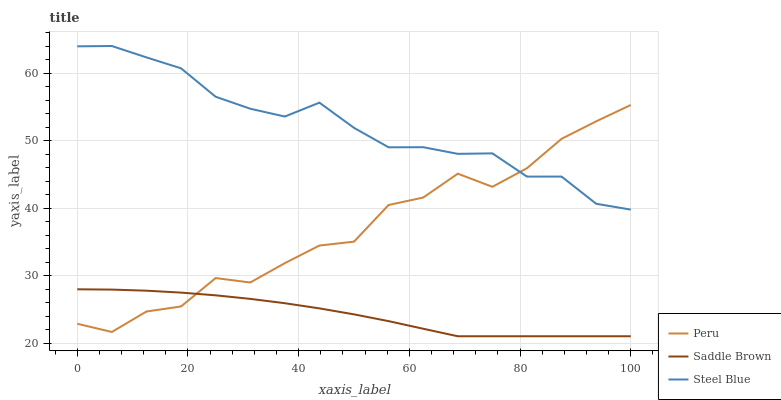Does Saddle Brown have the minimum area under the curve?
Answer yes or no. Yes. Does Steel Blue have the maximum area under the curve?
Answer yes or no. Yes. Does Peru have the minimum area under the curve?
Answer yes or no. No. Does Peru have the maximum area under the curve?
Answer yes or no. No. Is Saddle Brown the smoothest?
Answer yes or no. Yes. Is Peru the roughest?
Answer yes or no. Yes. Is Steel Blue the smoothest?
Answer yes or no. No. Is Steel Blue the roughest?
Answer yes or no. No. Does Peru have the lowest value?
Answer yes or no. No. Does Peru have the highest value?
Answer yes or no. No. Is Saddle Brown less than Steel Blue?
Answer yes or no. Yes. Is Steel Blue greater than Saddle Brown?
Answer yes or no. Yes. Does Saddle Brown intersect Steel Blue?
Answer yes or no. No. 